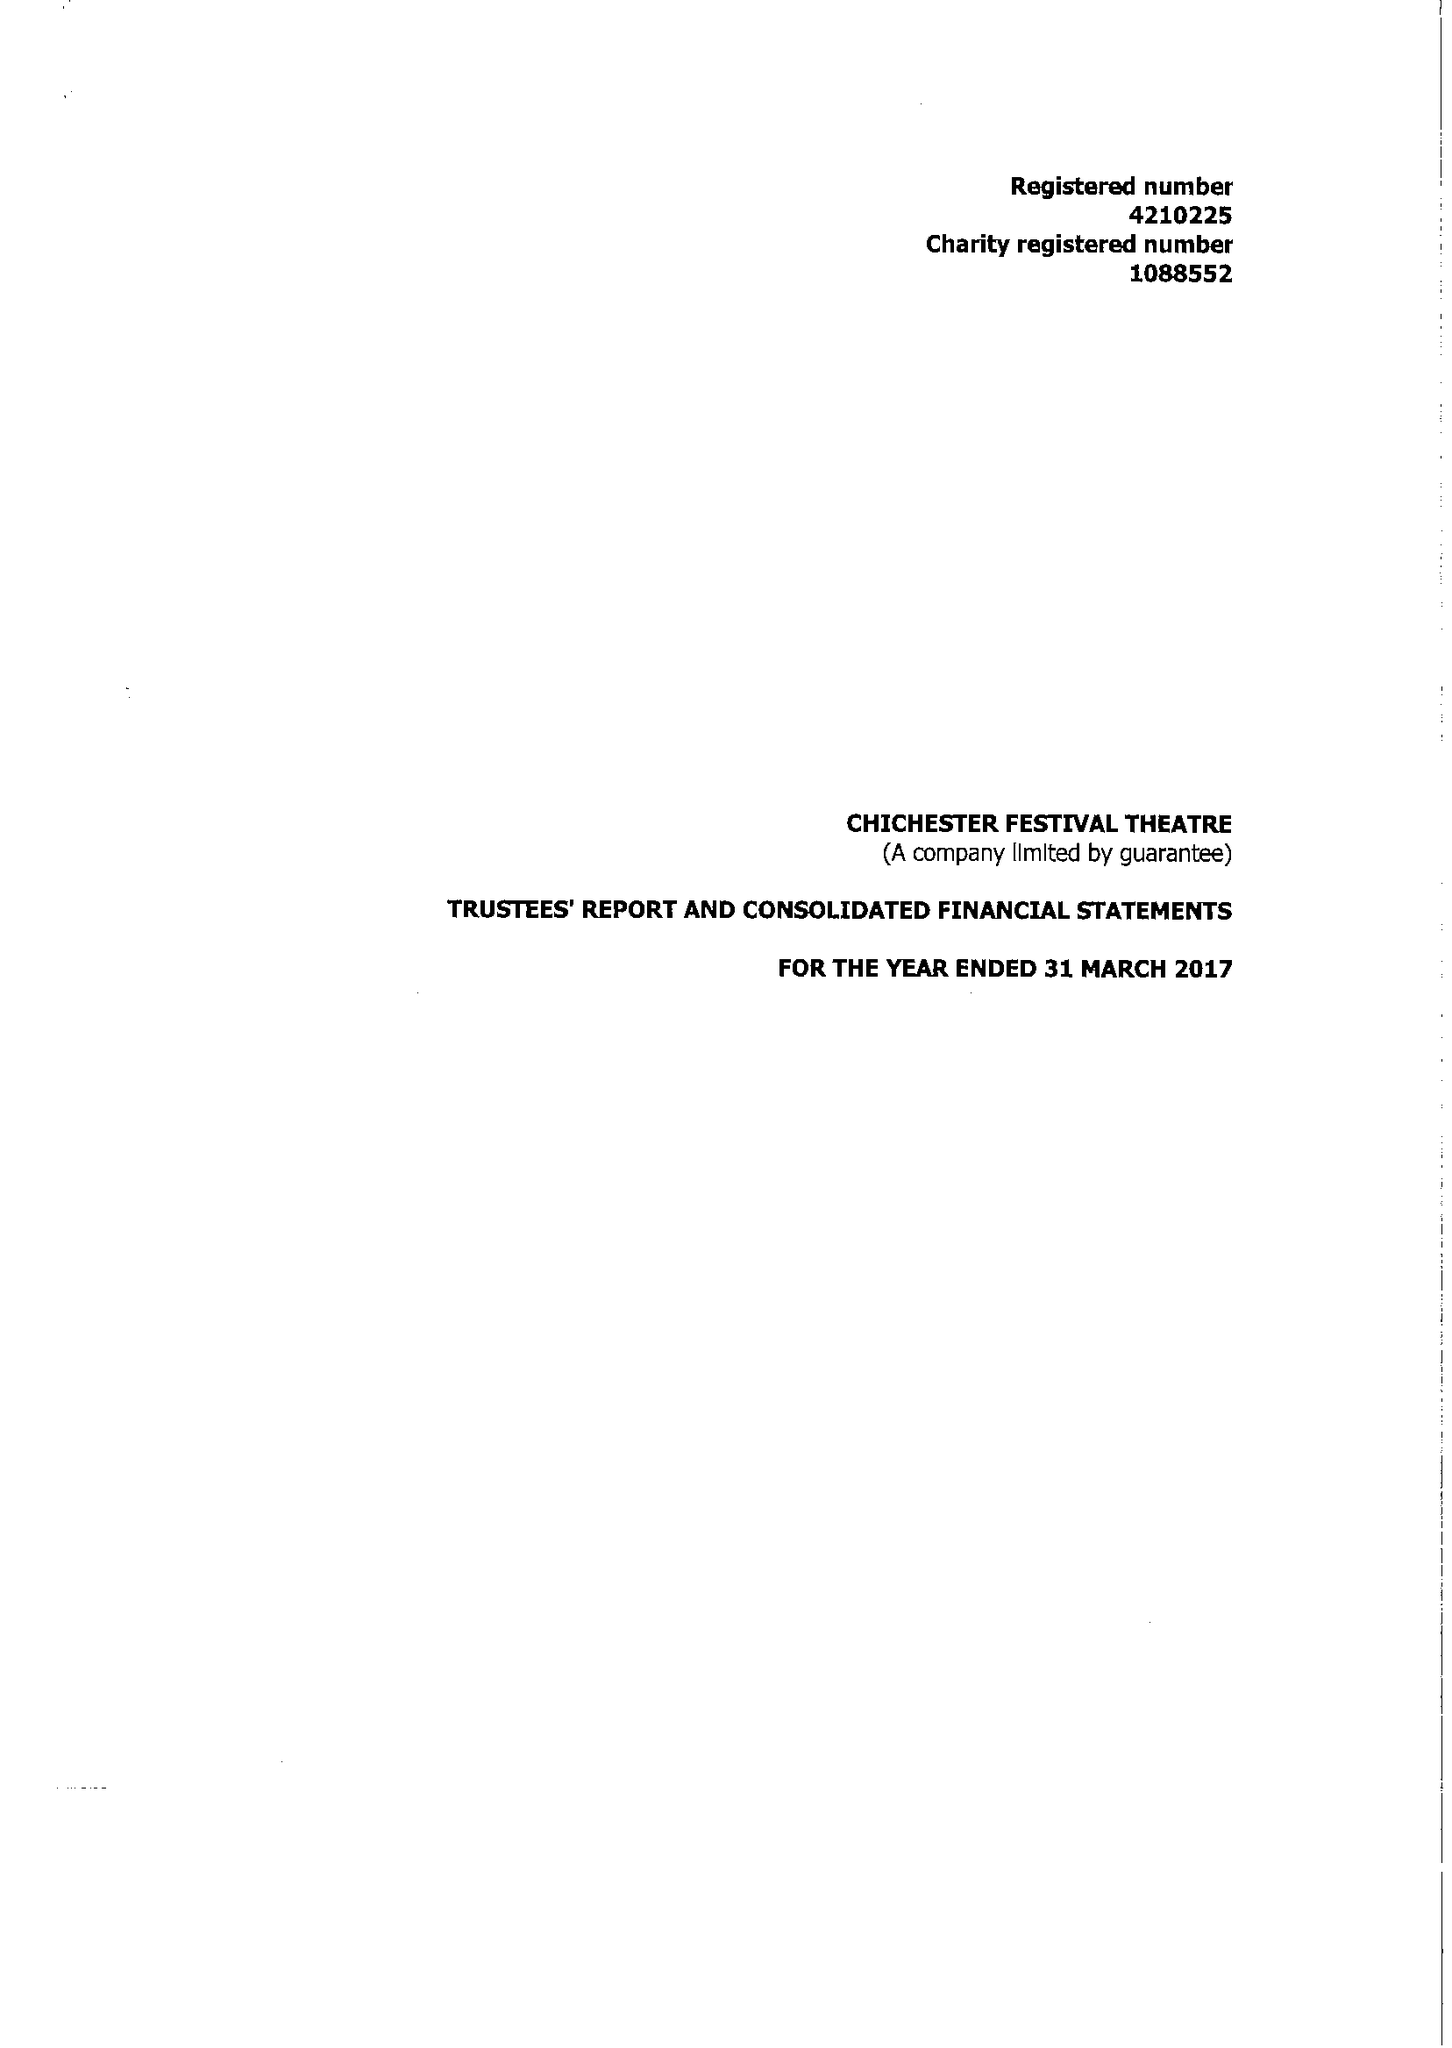What is the value for the address__street_line?
Answer the question using a single word or phrase. OAKLANDS PARK 